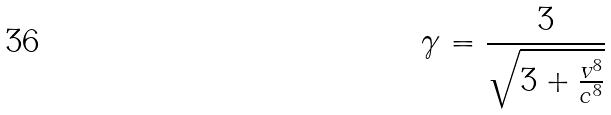Convert formula to latex. <formula><loc_0><loc_0><loc_500><loc_500>\gamma = \frac { 3 } { \sqrt { 3 + \frac { v ^ { 8 } } { c ^ { 8 } } } }</formula> 